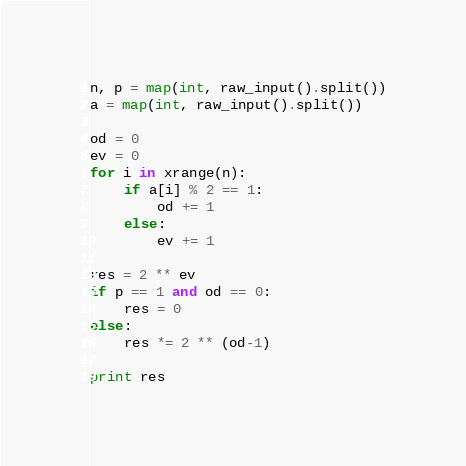<code> <loc_0><loc_0><loc_500><loc_500><_Python_>n, p = map(int, raw_input().split())
a = map(int, raw_input().split())

od = 0
ev = 0
for i in xrange(n):
    if a[i] % 2 == 1:
        od += 1
    else:
        ev += 1

res = 2 ** ev
if p == 1 and od == 0:
    res = 0
else:
    res *= 2 ** (od-1)

print res
</code> 